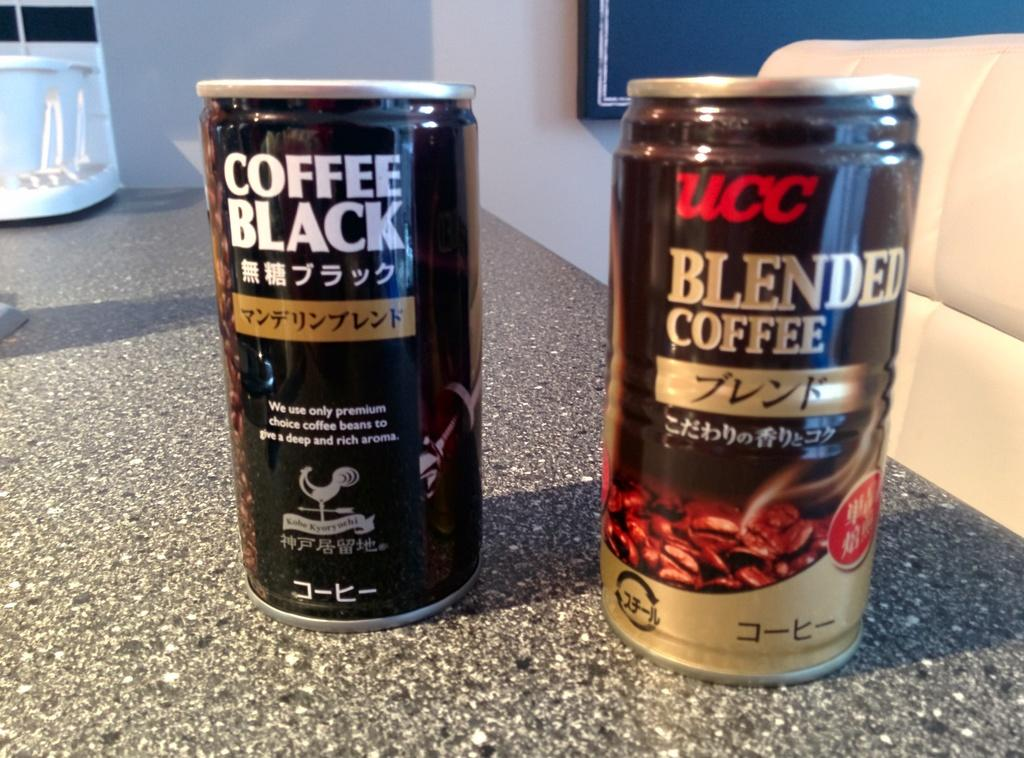<image>
Summarize the visual content of the image. two cans of coffee including a black and a blended 